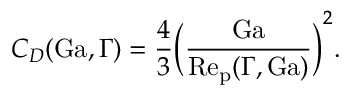Convert formula to latex. <formula><loc_0><loc_0><loc_500><loc_500>C _ { D } ( G a , \Gamma ) = \frac { 4 } { 3 } \left ( \frac { G a } { R e _ { p } ( \Gamma , G a ) } \right ) ^ { 2 } .</formula> 